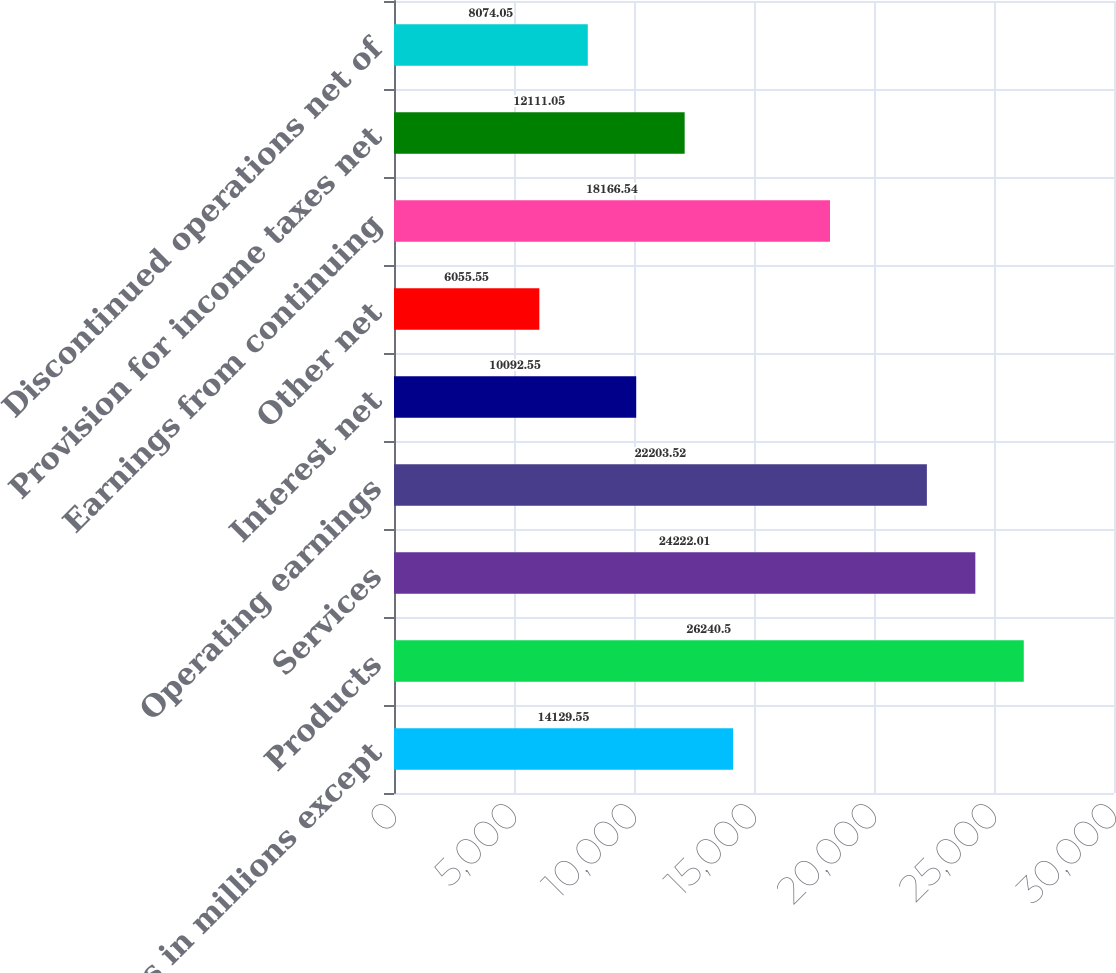<chart> <loc_0><loc_0><loc_500><loc_500><bar_chart><fcel>(Dollars in millions except<fcel>Products<fcel>Services<fcel>Operating earnings<fcel>Interest net<fcel>Other net<fcel>Earnings from continuing<fcel>Provision for income taxes net<fcel>Discontinued operations net of<nl><fcel>14129.5<fcel>26240.5<fcel>24222<fcel>22203.5<fcel>10092.5<fcel>6055.55<fcel>18166.5<fcel>12111<fcel>8074.05<nl></chart> 